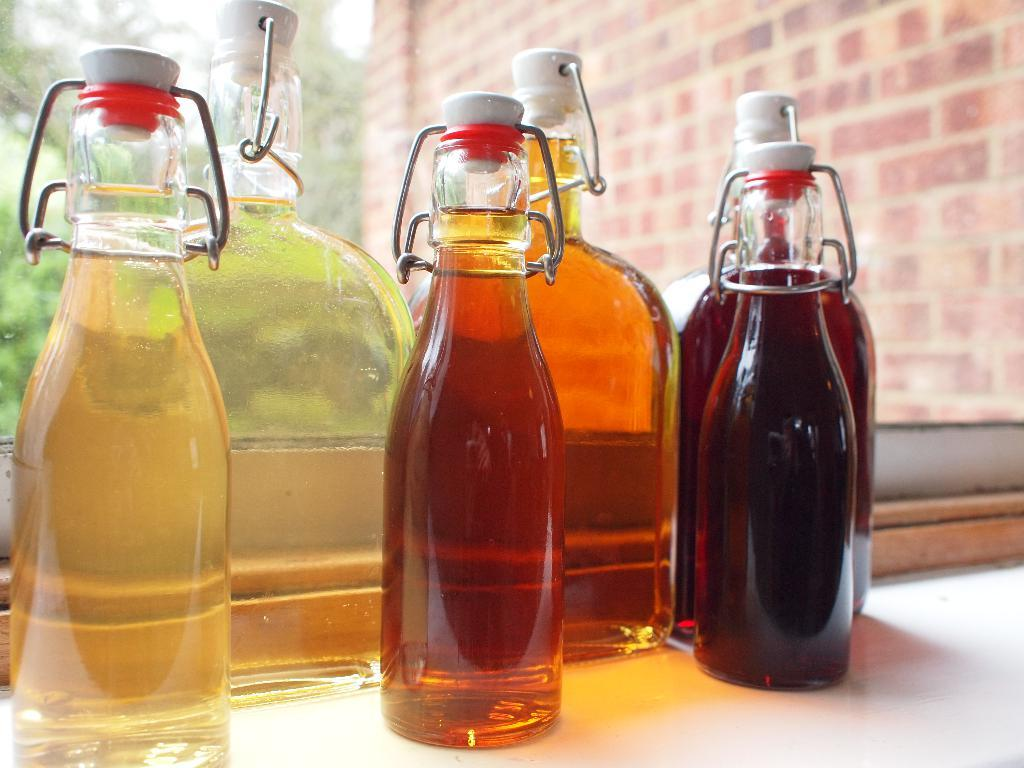What objects are in the image that are made of glass? There is a group of glass bottles in the image. What is inside the glass bottles? The glass bottles contain liquid. Where are the glass bottles located? The glass bottles are placed on a table. Is there a volcano erupting in the image? No, there is no volcano or any indication of an eruption in the image. Can you see a basketball being played with in the image? No, there is no basketball or any indication of a game being played in the image. 